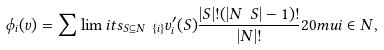<formula> <loc_0><loc_0><loc_500><loc_500>\phi _ { i } ( v ) = \sum \lim i t s _ { S \subseteq N \ \{ i \} } v ^ { \prime } _ { i } ( S ) \frac { | S | ! ( | N \ S | - 1 ) ! } { | N | ! } { 2 0 m u } i \in N ,</formula> 